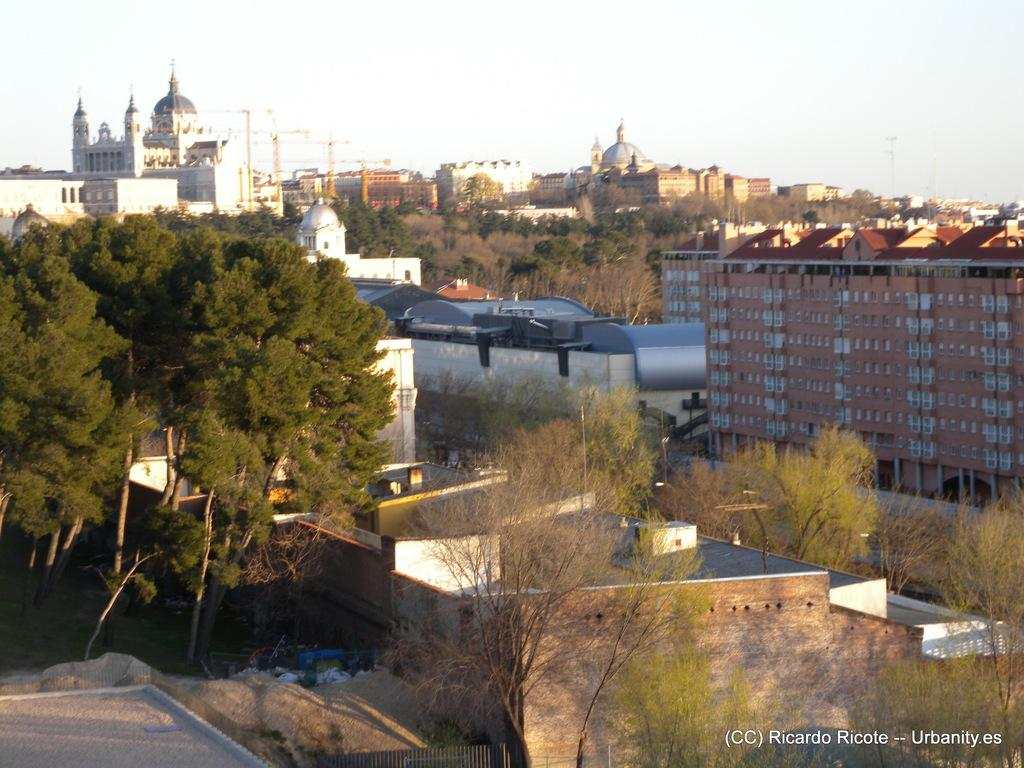What type of structures can be seen in the image? There are buildings in the image. What natural elements are present in the image? There are trees in the image. What construction equipment is visible in the image? There are cranes in the image. What is visible in the background of the image? The sky is visible in the image. How many friends are sitting on the bench in the image? There is no bench or friends present in the image. What type of burn is visible on the tree in the image? There is no burn or tree present in the image. 